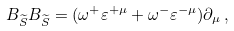<formula> <loc_0><loc_0><loc_500><loc_500>B _ { \widetilde { S } } B _ { \widetilde { S } } = ( \omega ^ { + } \varepsilon ^ { + \mu } + \omega ^ { - } \varepsilon ^ { - \mu } ) \partial _ { \mu } \, ,</formula> 